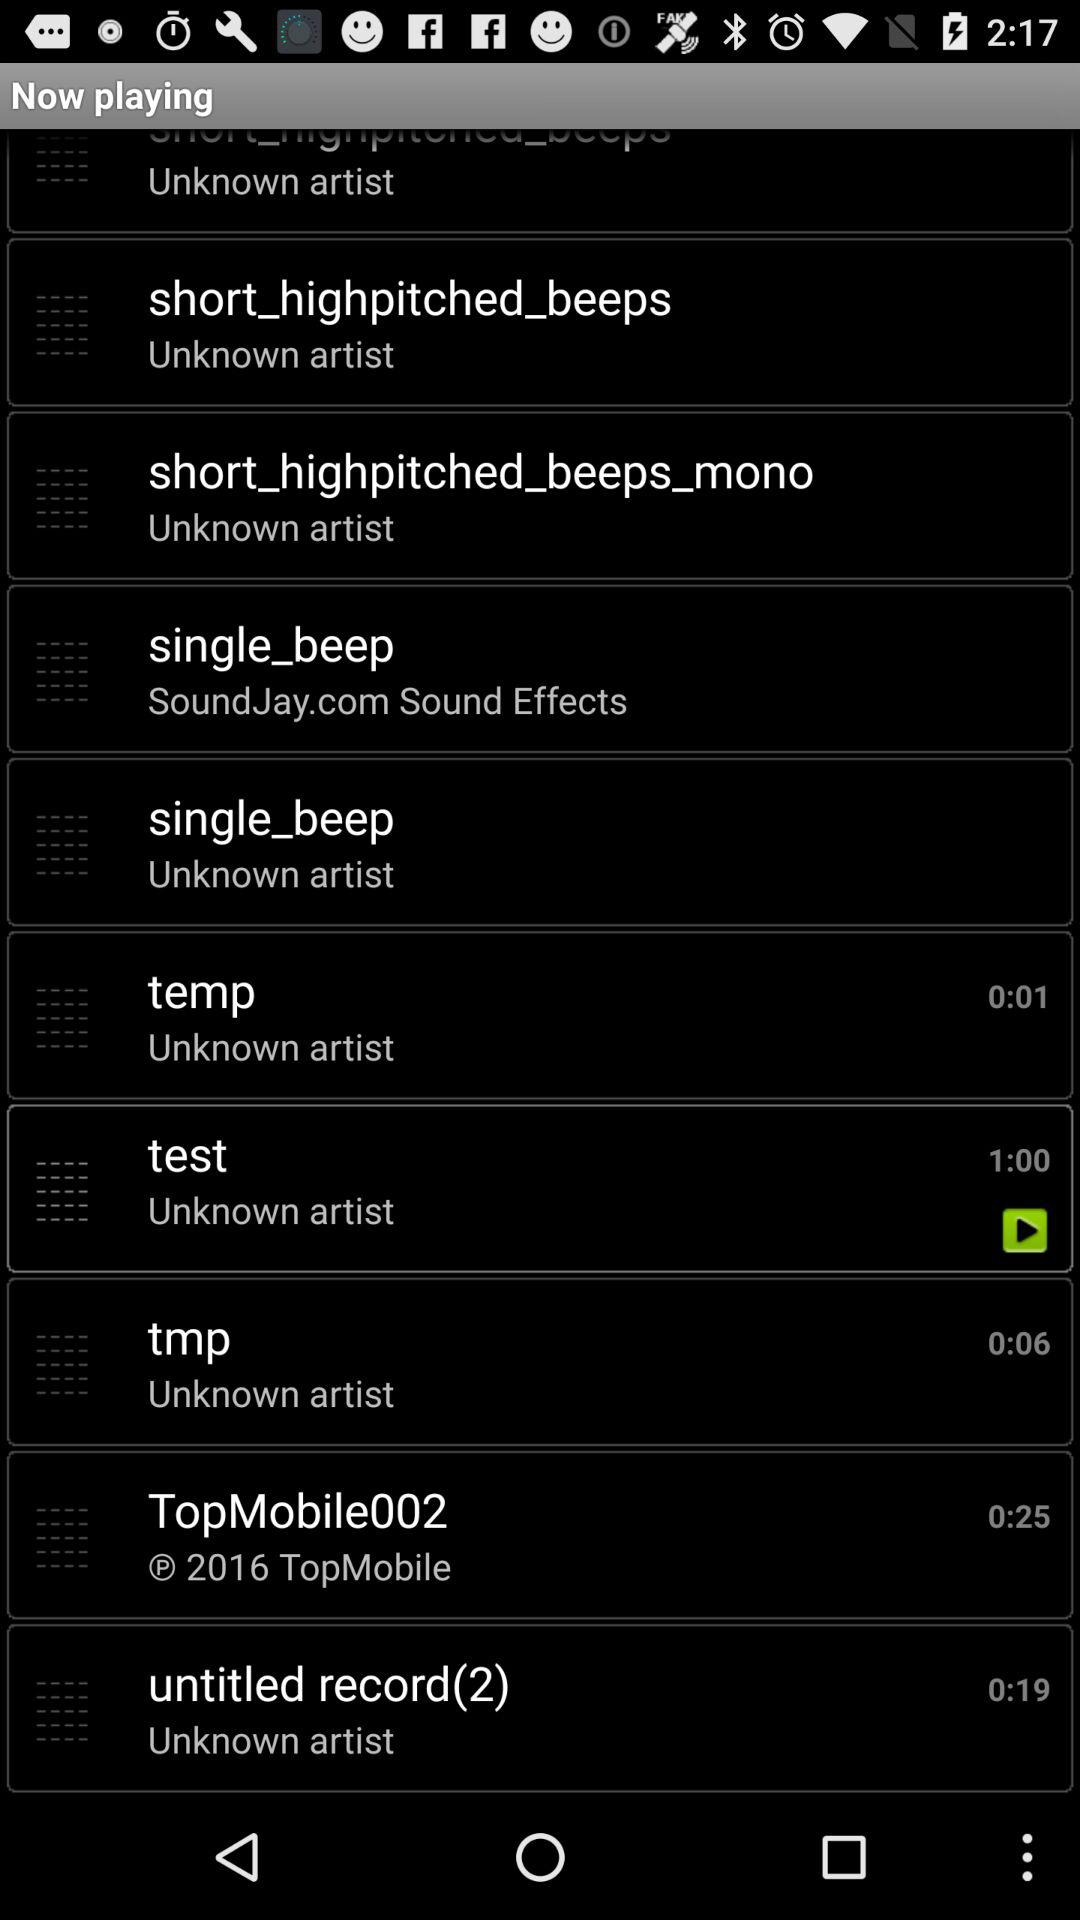What is the web address of a single beep?
When the provided information is insufficient, respond with <no answer>. <no answer> 